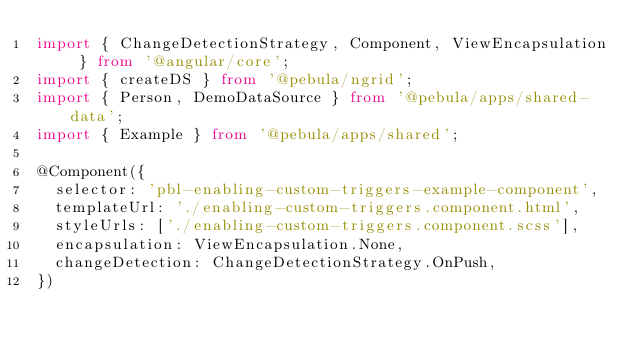<code> <loc_0><loc_0><loc_500><loc_500><_TypeScript_>import { ChangeDetectionStrategy, Component, ViewEncapsulation } from '@angular/core';
import { createDS } from '@pebula/ngrid';
import { Person, DemoDataSource } from '@pebula/apps/shared-data';
import { Example } from '@pebula/apps/shared';

@Component({
  selector: 'pbl-enabling-custom-triggers-example-component',
  templateUrl: './enabling-custom-triggers.component.html',
  styleUrls: ['./enabling-custom-triggers.component.scss'],
  encapsulation: ViewEncapsulation.None,
  changeDetection: ChangeDetectionStrategy.OnPush,
})</code> 